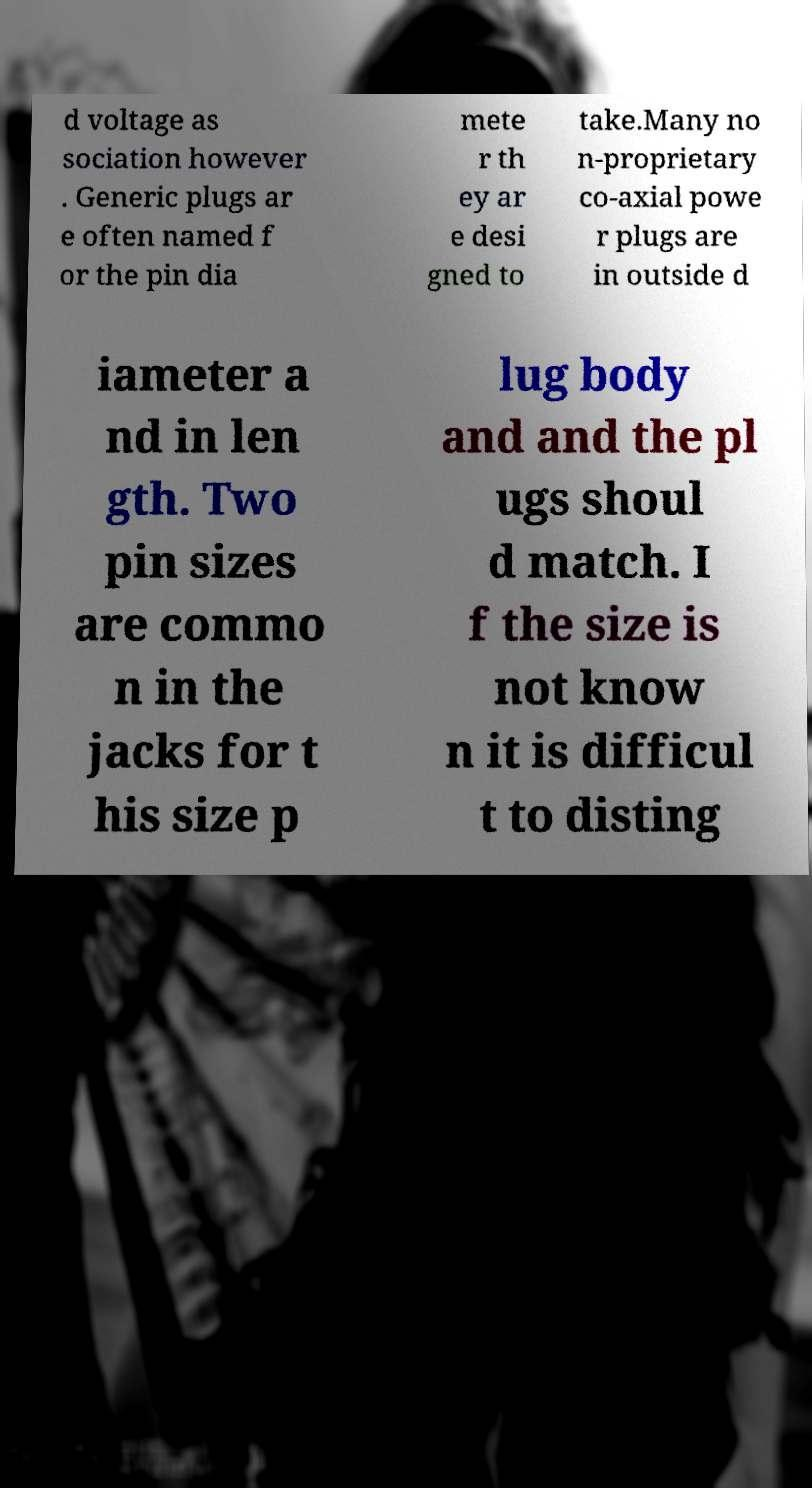For documentation purposes, I need the text within this image transcribed. Could you provide that? d voltage as sociation however . Generic plugs ar e often named f or the pin dia mete r th ey ar e desi gned to take.Many no n-proprietary co-axial powe r plugs are in outside d iameter a nd in len gth. Two pin sizes are commo n in the jacks for t his size p lug body and and the pl ugs shoul d match. I f the size is not know n it is difficul t to disting 